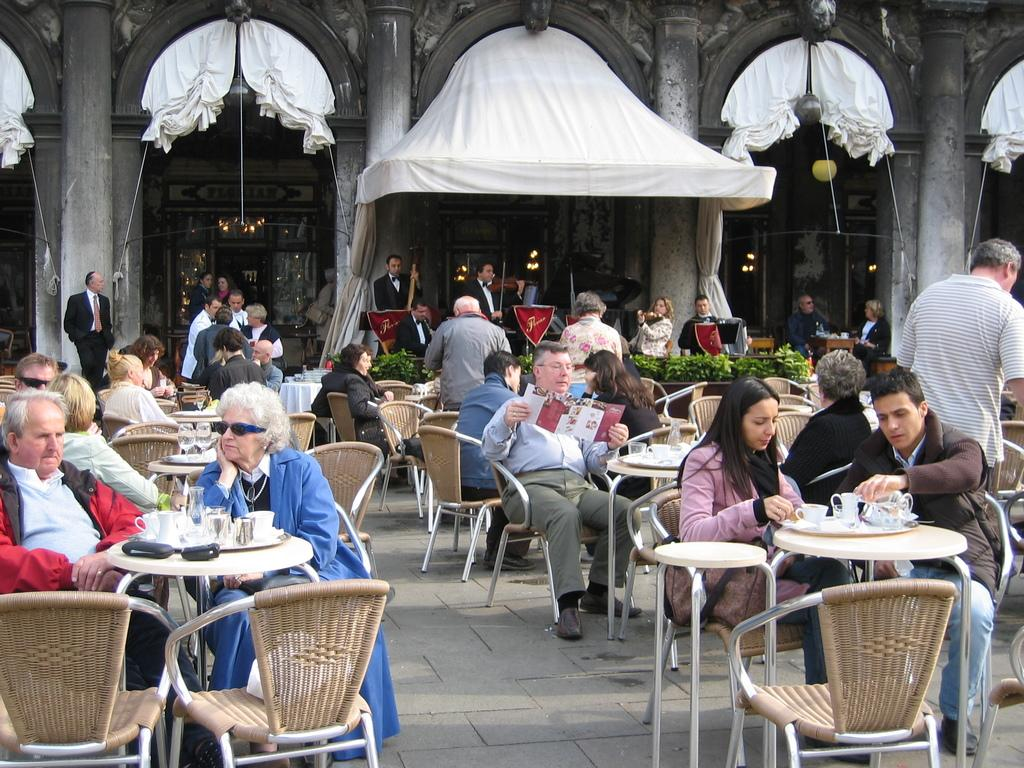What are the people in the image doing? The people in the image are sitting on chairs. What objects are in front of the chairs? There are tables in front of the chairs. What can be seen in the distance behind the people? There is a building visible in the background of the image. Can you see a patch of grass near the people in the image? There is no patch of grass visible in the image; it appears to be a paved or indoor area. What credit card is the person using to pay for their meal in the image? There is no credit card or payment transaction depicted in the image. 